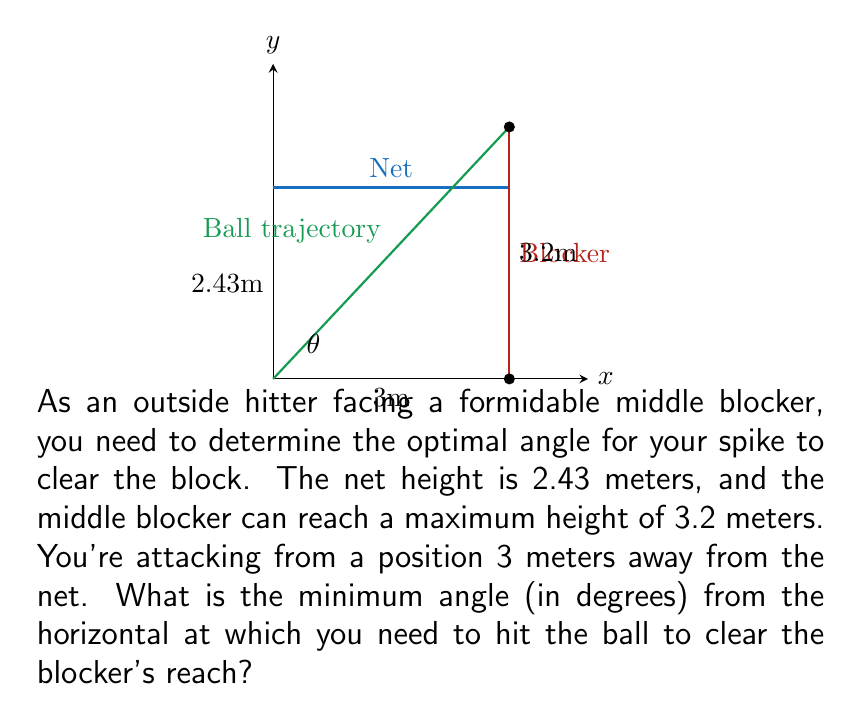Teach me how to tackle this problem. To solve this problem, we'll use trigonometry. Let's break it down step-by-step:

1) First, we need to find the height difference between the blocker's reach and the net:
   $\Delta h = 3.2 \text{ m} - 2.43 \text{ m} = 0.77 \text{ m}$

2) Now, we have a right triangle where:
   - The base (adjacent side) is 3 meters (distance from net)
   - The height (opposite side) is 0.77 meters (height to clear)
   - We need to find the angle θ

3) We can use the tangent function to find this angle:
   $\tan(\theta) = \frac{\text{opposite}}{\text{adjacent}} = \frac{0.77}{3}$

4) To get θ, we need to use the inverse tangent (arctangent) function:
   $\theta = \arctan(\frac{0.77}{3})$

5) Calculate this value:
   $\theta = \arctan(0.2566666...) \approx 0.2512 \text{ radians}$

6) Convert radians to degrees:
   $\theta \text{ (in degrees)} = 0.2512 \times \frac{180}{\pi} \approx 14.39°$

Therefore, the minimum angle needed is approximately 14.39 degrees from the horizontal.
Answer: $14.39°$ 